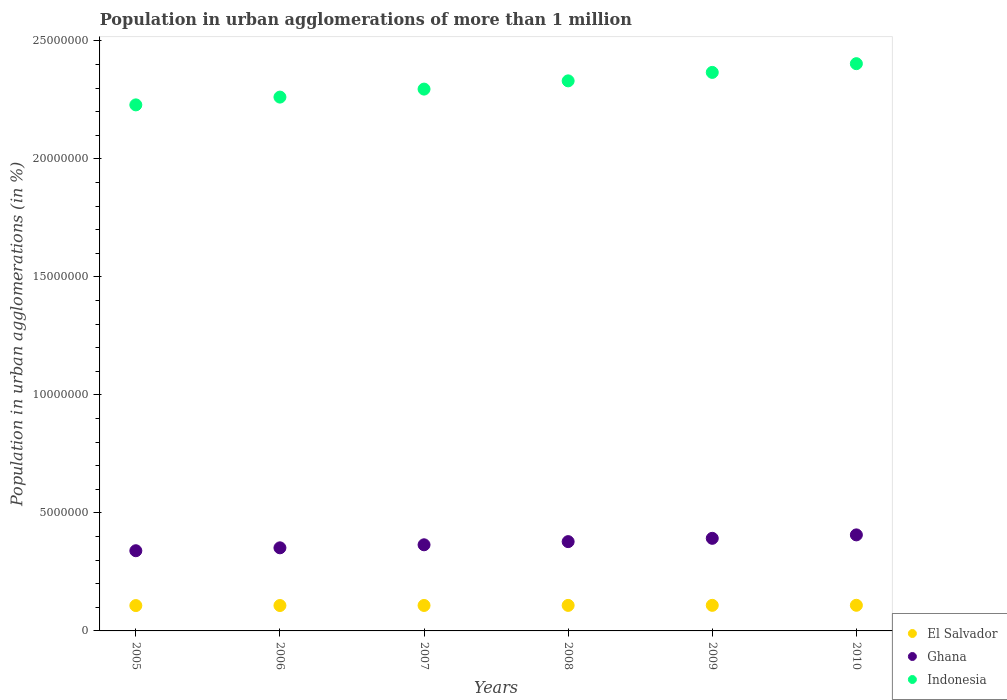What is the population in urban agglomerations in El Salvador in 2008?
Provide a short and direct response. 1.08e+06. Across all years, what is the maximum population in urban agglomerations in Indonesia?
Make the answer very short. 2.40e+07. Across all years, what is the minimum population in urban agglomerations in Indonesia?
Offer a very short reply. 2.23e+07. What is the total population in urban agglomerations in Indonesia in the graph?
Provide a succinct answer. 1.39e+08. What is the difference between the population in urban agglomerations in Ghana in 2009 and that in 2010?
Offer a terse response. -1.46e+05. What is the difference between the population in urban agglomerations in Ghana in 2006 and the population in urban agglomerations in El Salvador in 2010?
Ensure brevity in your answer.  2.43e+06. What is the average population in urban agglomerations in Indonesia per year?
Your response must be concise. 2.31e+07. In the year 2006, what is the difference between the population in urban agglomerations in Ghana and population in urban agglomerations in Indonesia?
Keep it short and to the point. -1.91e+07. What is the ratio of the population in urban agglomerations in El Salvador in 2008 to that in 2010?
Your answer should be compact. 1. Is the population in urban agglomerations in Ghana in 2008 less than that in 2009?
Provide a short and direct response. Yes. What is the difference between the highest and the second highest population in urban agglomerations in Ghana?
Ensure brevity in your answer.  1.46e+05. What is the difference between the highest and the lowest population in urban agglomerations in El Salvador?
Make the answer very short. 1.25e+04. Does the population in urban agglomerations in Indonesia monotonically increase over the years?
Your answer should be compact. Yes. Is the population in urban agglomerations in Indonesia strictly less than the population in urban agglomerations in Ghana over the years?
Give a very brief answer. No. How many dotlines are there?
Your response must be concise. 3. How many years are there in the graph?
Keep it short and to the point. 6. Does the graph contain grids?
Keep it short and to the point. No. How are the legend labels stacked?
Make the answer very short. Vertical. What is the title of the graph?
Provide a succinct answer. Population in urban agglomerations of more than 1 million. What is the label or title of the Y-axis?
Your answer should be compact. Population in urban agglomerations (in %). What is the Population in urban agglomerations (in %) in El Salvador in 2005?
Your answer should be compact. 1.07e+06. What is the Population in urban agglomerations (in %) of Ghana in 2005?
Your answer should be compact. 3.40e+06. What is the Population in urban agglomerations (in %) in Indonesia in 2005?
Offer a terse response. 2.23e+07. What is the Population in urban agglomerations (in %) in El Salvador in 2006?
Offer a very short reply. 1.08e+06. What is the Population in urban agglomerations (in %) in Ghana in 2006?
Offer a very short reply. 3.52e+06. What is the Population in urban agglomerations (in %) of Indonesia in 2006?
Your answer should be compact. 2.26e+07. What is the Population in urban agglomerations (in %) in El Salvador in 2007?
Make the answer very short. 1.08e+06. What is the Population in urban agglomerations (in %) of Ghana in 2007?
Your answer should be compact. 3.65e+06. What is the Population in urban agglomerations (in %) of Indonesia in 2007?
Keep it short and to the point. 2.30e+07. What is the Population in urban agglomerations (in %) in El Salvador in 2008?
Your answer should be very brief. 1.08e+06. What is the Population in urban agglomerations (in %) of Ghana in 2008?
Provide a short and direct response. 3.78e+06. What is the Population in urban agglomerations (in %) of Indonesia in 2008?
Make the answer very short. 2.33e+07. What is the Population in urban agglomerations (in %) of El Salvador in 2009?
Your answer should be compact. 1.08e+06. What is the Population in urban agglomerations (in %) in Ghana in 2009?
Offer a terse response. 3.92e+06. What is the Population in urban agglomerations (in %) of Indonesia in 2009?
Provide a succinct answer. 2.37e+07. What is the Population in urban agglomerations (in %) in El Salvador in 2010?
Provide a short and direct response. 1.09e+06. What is the Population in urban agglomerations (in %) of Ghana in 2010?
Offer a very short reply. 4.07e+06. What is the Population in urban agglomerations (in %) in Indonesia in 2010?
Provide a short and direct response. 2.40e+07. Across all years, what is the maximum Population in urban agglomerations (in %) of El Salvador?
Offer a terse response. 1.09e+06. Across all years, what is the maximum Population in urban agglomerations (in %) of Ghana?
Give a very brief answer. 4.07e+06. Across all years, what is the maximum Population in urban agglomerations (in %) in Indonesia?
Give a very brief answer. 2.40e+07. Across all years, what is the minimum Population in urban agglomerations (in %) in El Salvador?
Your answer should be very brief. 1.07e+06. Across all years, what is the minimum Population in urban agglomerations (in %) in Ghana?
Provide a short and direct response. 3.40e+06. Across all years, what is the minimum Population in urban agglomerations (in %) of Indonesia?
Make the answer very short. 2.23e+07. What is the total Population in urban agglomerations (in %) of El Salvador in the graph?
Keep it short and to the point. 6.48e+06. What is the total Population in urban agglomerations (in %) of Ghana in the graph?
Provide a short and direct response. 2.23e+07. What is the total Population in urban agglomerations (in %) of Indonesia in the graph?
Offer a very short reply. 1.39e+08. What is the difference between the Population in urban agglomerations (in %) of El Salvador in 2005 and that in 2006?
Offer a very short reply. -2485. What is the difference between the Population in urban agglomerations (in %) in Ghana in 2005 and that in 2006?
Provide a short and direct response. -1.23e+05. What is the difference between the Population in urban agglomerations (in %) of Indonesia in 2005 and that in 2006?
Give a very brief answer. -3.30e+05. What is the difference between the Population in urban agglomerations (in %) of El Salvador in 2005 and that in 2007?
Your answer should be compact. -4976. What is the difference between the Population in urban agglomerations (in %) in Ghana in 2005 and that in 2007?
Provide a short and direct response. -2.52e+05. What is the difference between the Population in urban agglomerations (in %) in Indonesia in 2005 and that in 2007?
Your answer should be compact. -6.69e+05. What is the difference between the Population in urban agglomerations (in %) in El Salvador in 2005 and that in 2008?
Provide a succinct answer. -7476. What is the difference between the Population in urban agglomerations (in %) in Ghana in 2005 and that in 2008?
Offer a very short reply. -3.86e+05. What is the difference between the Population in urban agglomerations (in %) of Indonesia in 2005 and that in 2008?
Give a very brief answer. -1.02e+06. What is the difference between the Population in urban agglomerations (in %) in El Salvador in 2005 and that in 2009?
Your answer should be very brief. -9974. What is the difference between the Population in urban agglomerations (in %) of Ghana in 2005 and that in 2009?
Give a very brief answer. -5.26e+05. What is the difference between the Population in urban agglomerations (in %) in Indonesia in 2005 and that in 2009?
Offer a terse response. -1.38e+06. What is the difference between the Population in urban agglomerations (in %) of El Salvador in 2005 and that in 2010?
Provide a succinct answer. -1.25e+04. What is the difference between the Population in urban agglomerations (in %) in Ghana in 2005 and that in 2010?
Make the answer very short. -6.72e+05. What is the difference between the Population in urban agglomerations (in %) of Indonesia in 2005 and that in 2010?
Provide a short and direct response. -1.75e+06. What is the difference between the Population in urban agglomerations (in %) of El Salvador in 2006 and that in 2007?
Ensure brevity in your answer.  -2491. What is the difference between the Population in urban agglomerations (in %) of Ghana in 2006 and that in 2007?
Provide a short and direct response. -1.28e+05. What is the difference between the Population in urban agglomerations (in %) in Indonesia in 2006 and that in 2007?
Provide a succinct answer. -3.39e+05. What is the difference between the Population in urban agglomerations (in %) in El Salvador in 2006 and that in 2008?
Give a very brief answer. -4991. What is the difference between the Population in urban agglomerations (in %) in Ghana in 2006 and that in 2008?
Provide a succinct answer. -2.63e+05. What is the difference between the Population in urban agglomerations (in %) of Indonesia in 2006 and that in 2008?
Make the answer very short. -6.88e+05. What is the difference between the Population in urban agglomerations (in %) in El Salvador in 2006 and that in 2009?
Offer a very short reply. -7489. What is the difference between the Population in urban agglomerations (in %) in Ghana in 2006 and that in 2009?
Offer a terse response. -4.02e+05. What is the difference between the Population in urban agglomerations (in %) in Indonesia in 2006 and that in 2009?
Your answer should be very brief. -1.05e+06. What is the difference between the Population in urban agglomerations (in %) in El Salvador in 2006 and that in 2010?
Offer a very short reply. -9998. What is the difference between the Population in urban agglomerations (in %) of Ghana in 2006 and that in 2010?
Your response must be concise. -5.49e+05. What is the difference between the Population in urban agglomerations (in %) in Indonesia in 2006 and that in 2010?
Your answer should be very brief. -1.42e+06. What is the difference between the Population in urban agglomerations (in %) of El Salvador in 2007 and that in 2008?
Offer a terse response. -2500. What is the difference between the Population in urban agglomerations (in %) in Ghana in 2007 and that in 2008?
Your answer should be compact. -1.34e+05. What is the difference between the Population in urban agglomerations (in %) of Indonesia in 2007 and that in 2008?
Give a very brief answer. -3.49e+05. What is the difference between the Population in urban agglomerations (in %) of El Salvador in 2007 and that in 2009?
Your response must be concise. -4998. What is the difference between the Population in urban agglomerations (in %) of Ghana in 2007 and that in 2009?
Offer a terse response. -2.74e+05. What is the difference between the Population in urban agglomerations (in %) in Indonesia in 2007 and that in 2009?
Make the answer very short. -7.08e+05. What is the difference between the Population in urban agglomerations (in %) of El Salvador in 2007 and that in 2010?
Make the answer very short. -7507. What is the difference between the Population in urban agglomerations (in %) of Ghana in 2007 and that in 2010?
Your response must be concise. -4.20e+05. What is the difference between the Population in urban agglomerations (in %) in Indonesia in 2007 and that in 2010?
Provide a succinct answer. -1.08e+06. What is the difference between the Population in urban agglomerations (in %) of El Salvador in 2008 and that in 2009?
Keep it short and to the point. -2498. What is the difference between the Population in urban agglomerations (in %) of Ghana in 2008 and that in 2009?
Provide a succinct answer. -1.40e+05. What is the difference between the Population in urban agglomerations (in %) of Indonesia in 2008 and that in 2009?
Provide a succinct answer. -3.59e+05. What is the difference between the Population in urban agglomerations (in %) of El Salvador in 2008 and that in 2010?
Your response must be concise. -5007. What is the difference between the Population in urban agglomerations (in %) of Ghana in 2008 and that in 2010?
Your response must be concise. -2.86e+05. What is the difference between the Population in urban agglomerations (in %) of Indonesia in 2008 and that in 2010?
Make the answer very short. -7.28e+05. What is the difference between the Population in urban agglomerations (in %) of El Salvador in 2009 and that in 2010?
Offer a very short reply. -2509. What is the difference between the Population in urban agglomerations (in %) in Ghana in 2009 and that in 2010?
Offer a terse response. -1.46e+05. What is the difference between the Population in urban agglomerations (in %) of Indonesia in 2009 and that in 2010?
Your answer should be compact. -3.70e+05. What is the difference between the Population in urban agglomerations (in %) of El Salvador in 2005 and the Population in urban agglomerations (in %) of Ghana in 2006?
Your answer should be very brief. -2.45e+06. What is the difference between the Population in urban agglomerations (in %) of El Salvador in 2005 and the Population in urban agglomerations (in %) of Indonesia in 2006?
Offer a very short reply. -2.15e+07. What is the difference between the Population in urban agglomerations (in %) of Ghana in 2005 and the Population in urban agglomerations (in %) of Indonesia in 2006?
Provide a succinct answer. -1.92e+07. What is the difference between the Population in urban agglomerations (in %) in El Salvador in 2005 and the Population in urban agglomerations (in %) in Ghana in 2007?
Provide a succinct answer. -2.58e+06. What is the difference between the Population in urban agglomerations (in %) in El Salvador in 2005 and the Population in urban agglomerations (in %) in Indonesia in 2007?
Ensure brevity in your answer.  -2.19e+07. What is the difference between the Population in urban agglomerations (in %) in Ghana in 2005 and the Population in urban agglomerations (in %) in Indonesia in 2007?
Your answer should be very brief. -1.96e+07. What is the difference between the Population in urban agglomerations (in %) in El Salvador in 2005 and the Population in urban agglomerations (in %) in Ghana in 2008?
Make the answer very short. -2.71e+06. What is the difference between the Population in urban agglomerations (in %) in El Salvador in 2005 and the Population in urban agglomerations (in %) in Indonesia in 2008?
Make the answer very short. -2.22e+07. What is the difference between the Population in urban agglomerations (in %) of Ghana in 2005 and the Population in urban agglomerations (in %) of Indonesia in 2008?
Offer a terse response. -1.99e+07. What is the difference between the Population in urban agglomerations (in %) in El Salvador in 2005 and the Population in urban agglomerations (in %) in Ghana in 2009?
Give a very brief answer. -2.85e+06. What is the difference between the Population in urban agglomerations (in %) in El Salvador in 2005 and the Population in urban agglomerations (in %) in Indonesia in 2009?
Make the answer very short. -2.26e+07. What is the difference between the Population in urban agglomerations (in %) in Ghana in 2005 and the Population in urban agglomerations (in %) in Indonesia in 2009?
Keep it short and to the point. -2.03e+07. What is the difference between the Population in urban agglomerations (in %) of El Salvador in 2005 and the Population in urban agglomerations (in %) of Ghana in 2010?
Your answer should be very brief. -3.00e+06. What is the difference between the Population in urban agglomerations (in %) of El Salvador in 2005 and the Population in urban agglomerations (in %) of Indonesia in 2010?
Your answer should be very brief. -2.30e+07. What is the difference between the Population in urban agglomerations (in %) in Ghana in 2005 and the Population in urban agglomerations (in %) in Indonesia in 2010?
Make the answer very short. -2.06e+07. What is the difference between the Population in urban agglomerations (in %) in El Salvador in 2006 and the Population in urban agglomerations (in %) in Ghana in 2007?
Keep it short and to the point. -2.57e+06. What is the difference between the Population in urban agglomerations (in %) of El Salvador in 2006 and the Population in urban agglomerations (in %) of Indonesia in 2007?
Make the answer very short. -2.19e+07. What is the difference between the Population in urban agglomerations (in %) in Ghana in 2006 and the Population in urban agglomerations (in %) in Indonesia in 2007?
Your answer should be compact. -1.94e+07. What is the difference between the Population in urban agglomerations (in %) in El Salvador in 2006 and the Population in urban agglomerations (in %) in Ghana in 2008?
Offer a very short reply. -2.71e+06. What is the difference between the Population in urban agglomerations (in %) in El Salvador in 2006 and the Population in urban agglomerations (in %) in Indonesia in 2008?
Your response must be concise. -2.22e+07. What is the difference between the Population in urban agglomerations (in %) in Ghana in 2006 and the Population in urban agglomerations (in %) in Indonesia in 2008?
Keep it short and to the point. -1.98e+07. What is the difference between the Population in urban agglomerations (in %) in El Salvador in 2006 and the Population in urban agglomerations (in %) in Ghana in 2009?
Give a very brief answer. -2.85e+06. What is the difference between the Population in urban agglomerations (in %) in El Salvador in 2006 and the Population in urban agglomerations (in %) in Indonesia in 2009?
Your response must be concise. -2.26e+07. What is the difference between the Population in urban agglomerations (in %) in Ghana in 2006 and the Population in urban agglomerations (in %) in Indonesia in 2009?
Make the answer very short. -2.01e+07. What is the difference between the Population in urban agglomerations (in %) in El Salvador in 2006 and the Population in urban agglomerations (in %) in Ghana in 2010?
Keep it short and to the point. -2.99e+06. What is the difference between the Population in urban agglomerations (in %) in El Salvador in 2006 and the Population in urban agglomerations (in %) in Indonesia in 2010?
Make the answer very short. -2.30e+07. What is the difference between the Population in urban agglomerations (in %) of Ghana in 2006 and the Population in urban agglomerations (in %) of Indonesia in 2010?
Your response must be concise. -2.05e+07. What is the difference between the Population in urban agglomerations (in %) of El Salvador in 2007 and the Population in urban agglomerations (in %) of Ghana in 2008?
Keep it short and to the point. -2.70e+06. What is the difference between the Population in urban agglomerations (in %) in El Salvador in 2007 and the Population in urban agglomerations (in %) in Indonesia in 2008?
Ensure brevity in your answer.  -2.22e+07. What is the difference between the Population in urban agglomerations (in %) of Ghana in 2007 and the Population in urban agglomerations (in %) of Indonesia in 2008?
Offer a terse response. -1.97e+07. What is the difference between the Population in urban agglomerations (in %) of El Salvador in 2007 and the Population in urban agglomerations (in %) of Ghana in 2009?
Your response must be concise. -2.84e+06. What is the difference between the Population in urban agglomerations (in %) of El Salvador in 2007 and the Population in urban agglomerations (in %) of Indonesia in 2009?
Offer a very short reply. -2.26e+07. What is the difference between the Population in urban agglomerations (in %) in Ghana in 2007 and the Population in urban agglomerations (in %) in Indonesia in 2009?
Make the answer very short. -2.00e+07. What is the difference between the Population in urban agglomerations (in %) of El Salvador in 2007 and the Population in urban agglomerations (in %) of Ghana in 2010?
Keep it short and to the point. -2.99e+06. What is the difference between the Population in urban agglomerations (in %) of El Salvador in 2007 and the Population in urban agglomerations (in %) of Indonesia in 2010?
Ensure brevity in your answer.  -2.30e+07. What is the difference between the Population in urban agglomerations (in %) of Ghana in 2007 and the Population in urban agglomerations (in %) of Indonesia in 2010?
Offer a terse response. -2.04e+07. What is the difference between the Population in urban agglomerations (in %) of El Salvador in 2008 and the Population in urban agglomerations (in %) of Ghana in 2009?
Offer a very short reply. -2.84e+06. What is the difference between the Population in urban agglomerations (in %) in El Salvador in 2008 and the Population in urban agglomerations (in %) in Indonesia in 2009?
Your response must be concise. -2.26e+07. What is the difference between the Population in urban agglomerations (in %) in Ghana in 2008 and the Population in urban agglomerations (in %) in Indonesia in 2009?
Make the answer very short. -1.99e+07. What is the difference between the Population in urban agglomerations (in %) of El Salvador in 2008 and the Population in urban agglomerations (in %) of Ghana in 2010?
Give a very brief answer. -2.99e+06. What is the difference between the Population in urban agglomerations (in %) of El Salvador in 2008 and the Population in urban agglomerations (in %) of Indonesia in 2010?
Your answer should be compact. -2.30e+07. What is the difference between the Population in urban agglomerations (in %) in Ghana in 2008 and the Population in urban agglomerations (in %) in Indonesia in 2010?
Provide a short and direct response. -2.03e+07. What is the difference between the Population in urban agglomerations (in %) of El Salvador in 2009 and the Population in urban agglomerations (in %) of Ghana in 2010?
Offer a very short reply. -2.99e+06. What is the difference between the Population in urban agglomerations (in %) of El Salvador in 2009 and the Population in urban agglomerations (in %) of Indonesia in 2010?
Your response must be concise. -2.30e+07. What is the difference between the Population in urban agglomerations (in %) of Ghana in 2009 and the Population in urban agglomerations (in %) of Indonesia in 2010?
Make the answer very short. -2.01e+07. What is the average Population in urban agglomerations (in %) of El Salvador per year?
Your answer should be very brief. 1.08e+06. What is the average Population in urban agglomerations (in %) of Ghana per year?
Provide a short and direct response. 3.72e+06. What is the average Population in urban agglomerations (in %) in Indonesia per year?
Your response must be concise. 2.31e+07. In the year 2005, what is the difference between the Population in urban agglomerations (in %) in El Salvador and Population in urban agglomerations (in %) in Ghana?
Give a very brief answer. -2.32e+06. In the year 2005, what is the difference between the Population in urban agglomerations (in %) in El Salvador and Population in urban agglomerations (in %) in Indonesia?
Keep it short and to the point. -2.12e+07. In the year 2005, what is the difference between the Population in urban agglomerations (in %) in Ghana and Population in urban agglomerations (in %) in Indonesia?
Your answer should be compact. -1.89e+07. In the year 2006, what is the difference between the Population in urban agglomerations (in %) of El Salvador and Population in urban agglomerations (in %) of Ghana?
Your response must be concise. -2.44e+06. In the year 2006, what is the difference between the Population in urban agglomerations (in %) of El Salvador and Population in urban agglomerations (in %) of Indonesia?
Offer a very short reply. -2.15e+07. In the year 2006, what is the difference between the Population in urban agglomerations (in %) in Ghana and Population in urban agglomerations (in %) in Indonesia?
Offer a terse response. -1.91e+07. In the year 2007, what is the difference between the Population in urban agglomerations (in %) of El Salvador and Population in urban agglomerations (in %) of Ghana?
Your answer should be compact. -2.57e+06. In the year 2007, what is the difference between the Population in urban agglomerations (in %) of El Salvador and Population in urban agglomerations (in %) of Indonesia?
Offer a very short reply. -2.19e+07. In the year 2007, what is the difference between the Population in urban agglomerations (in %) in Ghana and Population in urban agglomerations (in %) in Indonesia?
Ensure brevity in your answer.  -1.93e+07. In the year 2008, what is the difference between the Population in urban agglomerations (in %) of El Salvador and Population in urban agglomerations (in %) of Ghana?
Your answer should be very brief. -2.70e+06. In the year 2008, what is the difference between the Population in urban agglomerations (in %) in El Salvador and Population in urban agglomerations (in %) in Indonesia?
Provide a short and direct response. -2.22e+07. In the year 2008, what is the difference between the Population in urban agglomerations (in %) of Ghana and Population in urban agglomerations (in %) of Indonesia?
Your response must be concise. -1.95e+07. In the year 2009, what is the difference between the Population in urban agglomerations (in %) in El Salvador and Population in urban agglomerations (in %) in Ghana?
Your answer should be compact. -2.84e+06. In the year 2009, what is the difference between the Population in urban agglomerations (in %) in El Salvador and Population in urban agglomerations (in %) in Indonesia?
Your answer should be very brief. -2.26e+07. In the year 2009, what is the difference between the Population in urban agglomerations (in %) of Ghana and Population in urban agglomerations (in %) of Indonesia?
Make the answer very short. -1.97e+07. In the year 2010, what is the difference between the Population in urban agglomerations (in %) of El Salvador and Population in urban agglomerations (in %) of Ghana?
Offer a terse response. -2.98e+06. In the year 2010, what is the difference between the Population in urban agglomerations (in %) of El Salvador and Population in urban agglomerations (in %) of Indonesia?
Make the answer very short. -2.30e+07. In the year 2010, what is the difference between the Population in urban agglomerations (in %) of Ghana and Population in urban agglomerations (in %) of Indonesia?
Provide a succinct answer. -2.00e+07. What is the ratio of the Population in urban agglomerations (in %) of El Salvador in 2005 to that in 2006?
Provide a short and direct response. 1. What is the ratio of the Population in urban agglomerations (in %) of Indonesia in 2005 to that in 2006?
Make the answer very short. 0.99. What is the ratio of the Population in urban agglomerations (in %) in El Salvador in 2005 to that in 2007?
Make the answer very short. 1. What is the ratio of the Population in urban agglomerations (in %) in Ghana in 2005 to that in 2007?
Make the answer very short. 0.93. What is the ratio of the Population in urban agglomerations (in %) of Indonesia in 2005 to that in 2007?
Provide a succinct answer. 0.97. What is the ratio of the Population in urban agglomerations (in %) of El Salvador in 2005 to that in 2008?
Your answer should be very brief. 0.99. What is the ratio of the Population in urban agglomerations (in %) in Ghana in 2005 to that in 2008?
Provide a succinct answer. 0.9. What is the ratio of the Population in urban agglomerations (in %) in Indonesia in 2005 to that in 2008?
Offer a terse response. 0.96. What is the ratio of the Population in urban agglomerations (in %) of Ghana in 2005 to that in 2009?
Your answer should be very brief. 0.87. What is the ratio of the Population in urban agglomerations (in %) in Indonesia in 2005 to that in 2009?
Provide a succinct answer. 0.94. What is the ratio of the Population in urban agglomerations (in %) of Ghana in 2005 to that in 2010?
Your answer should be very brief. 0.83. What is the ratio of the Population in urban agglomerations (in %) in Indonesia in 2005 to that in 2010?
Make the answer very short. 0.93. What is the ratio of the Population in urban agglomerations (in %) of El Salvador in 2006 to that in 2007?
Offer a terse response. 1. What is the ratio of the Population in urban agglomerations (in %) of Ghana in 2006 to that in 2007?
Your answer should be compact. 0.96. What is the ratio of the Population in urban agglomerations (in %) of Indonesia in 2006 to that in 2007?
Offer a terse response. 0.99. What is the ratio of the Population in urban agglomerations (in %) in El Salvador in 2006 to that in 2008?
Make the answer very short. 1. What is the ratio of the Population in urban agglomerations (in %) in Ghana in 2006 to that in 2008?
Ensure brevity in your answer.  0.93. What is the ratio of the Population in urban agglomerations (in %) in Indonesia in 2006 to that in 2008?
Offer a very short reply. 0.97. What is the ratio of the Population in urban agglomerations (in %) of Ghana in 2006 to that in 2009?
Your answer should be very brief. 0.9. What is the ratio of the Population in urban agglomerations (in %) of Indonesia in 2006 to that in 2009?
Provide a short and direct response. 0.96. What is the ratio of the Population in urban agglomerations (in %) in Ghana in 2006 to that in 2010?
Make the answer very short. 0.87. What is the ratio of the Population in urban agglomerations (in %) in Indonesia in 2006 to that in 2010?
Your answer should be compact. 0.94. What is the ratio of the Population in urban agglomerations (in %) in El Salvador in 2007 to that in 2008?
Ensure brevity in your answer.  1. What is the ratio of the Population in urban agglomerations (in %) of Ghana in 2007 to that in 2008?
Your answer should be compact. 0.96. What is the ratio of the Population in urban agglomerations (in %) in Indonesia in 2007 to that in 2008?
Make the answer very short. 0.98. What is the ratio of the Population in urban agglomerations (in %) in El Salvador in 2007 to that in 2009?
Offer a very short reply. 1. What is the ratio of the Population in urban agglomerations (in %) of Ghana in 2007 to that in 2009?
Give a very brief answer. 0.93. What is the ratio of the Population in urban agglomerations (in %) of Indonesia in 2007 to that in 2009?
Make the answer very short. 0.97. What is the ratio of the Population in urban agglomerations (in %) in Ghana in 2007 to that in 2010?
Your answer should be compact. 0.9. What is the ratio of the Population in urban agglomerations (in %) in Indonesia in 2007 to that in 2010?
Offer a very short reply. 0.96. What is the ratio of the Population in urban agglomerations (in %) of Ghana in 2008 to that in 2009?
Ensure brevity in your answer.  0.96. What is the ratio of the Population in urban agglomerations (in %) of Indonesia in 2008 to that in 2009?
Offer a terse response. 0.98. What is the ratio of the Population in urban agglomerations (in %) in Ghana in 2008 to that in 2010?
Your response must be concise. 0.93. What is the ratio of the Population in urban agglomerations (in %) of Indonesia in 2008 to that in 2010?
Your answer should be compact. 0.97. What is the ratio of the Population in urban agglomerations (in %) in El Salvador in 2009 to that in 2010?
Offer a terse response. 1. What is the ratio of the Population in urban agglomerations (in %) of Ghana in 2009 to that in 2010?
Your answer should be very brief. 0.96. What is the ratio of the Population in urban agglomerations (in %) of Indonesia in 2009 to that in 2010?
Give a very brief answer. 0.98. What is the difference between the highest and the second highest Population in urban agglomerations (in %) of El Salvador?
Your answer should be very brief. 2509. What is the difference between the highest and the second highest Population in urban agglomerations (in %) of Ghana?
Your answer should be compact. 1.46e+05. What is the difference between the highest and the second highest Population in urban agglomerations (in %) of Indonesia?
Offer a terse response. 3.70e+05. What is the difference between the highest and the lowest Population in urban agglomerations (in %) of El Salvador?
Your answer should be very brief. 1.25e+04. What is the difference between the highest and the lowest Population in urban agglomerations (in %) of Ghana?
Offer a terse response. 6.72e+05. What is the difference between the highest and the lowest Population in urban agglomerations (in %) of Indonesia?
Provide a succinct answer. 1.75e+06. 